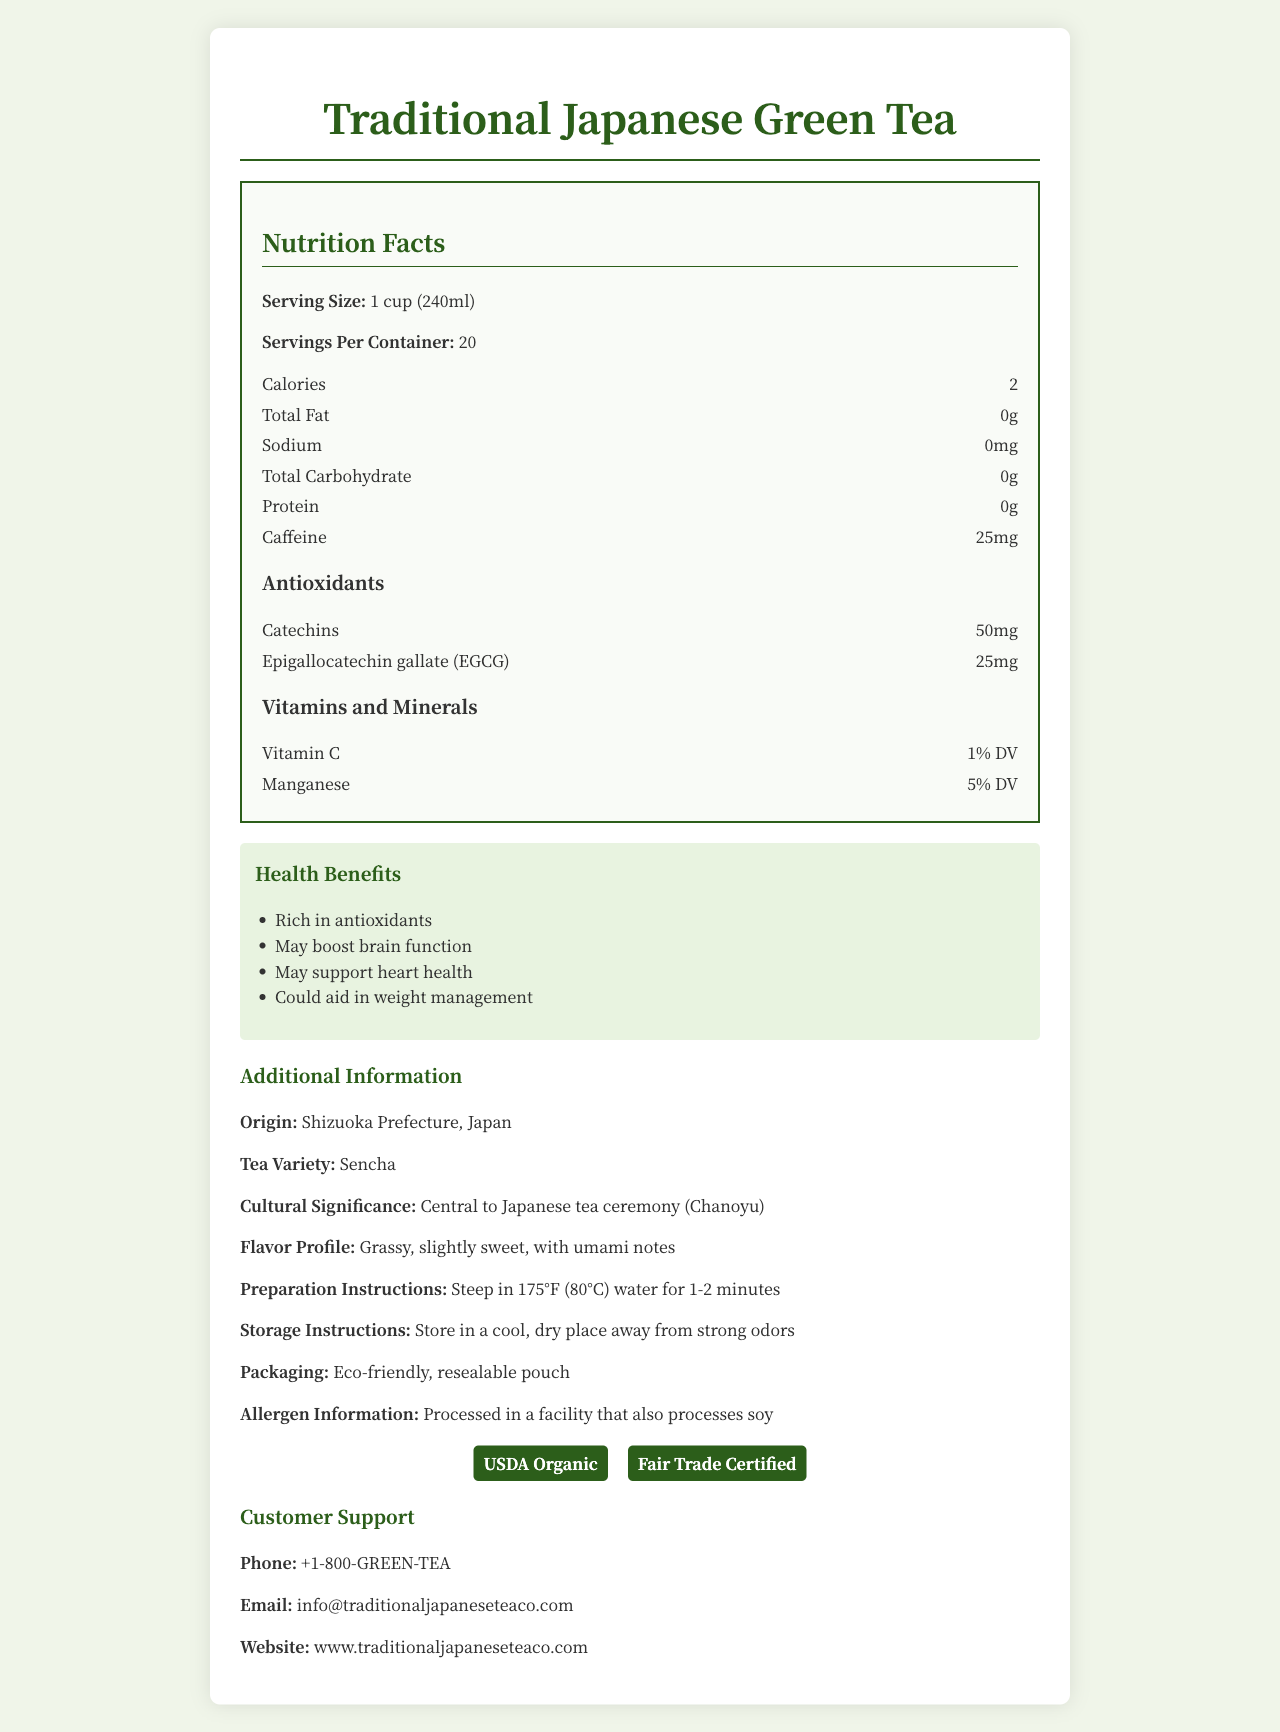what is the serving size of the Traditional Japanese Green Tea? The serving size is explicitly mentioned in the Nutrition Facts section of the document.
Answer: 1 cup (240ml) how many calories are in one serving of this green tea? The document states that each serving of the tea contains 2 calories.
Answer: 2 calories how much caffeine does each serving of the Green Tea contain? The Nutrition Facts section lists the caffeine content per serving as 25mg.
Answer: 25mg what antioxidants are found in this green tea and in what quantities? The Nutrition Facts section under 'Antioxidants' specifies the quantities for Catechins and EGCG.
Answer: Catechins: 50mg, Epigallocatechin gallate (EGCG): 25mg what percentage of the daily value of manganese does one serving provide? The document mentions that each serving provides 5% of the daily value (DV) for manganese.
Answer: 5% DV where is the origin of this green tea? The additional information section lists the origin as Shizuoka Prefecture in Japan.
Answer: Shizuoka Prefecture, Japan which health benefit is NOT listed for the green tea? A. May boost brain function B. Promotes skin health C. May support heart health D. Could aid in weight management The listed health benefits include brain function, heart health, and weight management, but not skin health.
Answer: B what certifications does the Traditional Japanese Green Tea have? A. USDA Organic B. Non-GMO Project Verified C. Fair Trade Certified D. Rainforest Alliance Certified The certifications listed in the document are USDA Organic and Fair Trade Certified.
Answer: A and C is the Traditional Japanese Green Tea allergen-free? The document states that it is processed in a facility that also processes soy, indicating a potential allergen.
Answer: No summarize the main information presented in the document. The document provides comprehensive details about the nutritional content, health benefits, and other key information about Traditional Japanese Green Tea from Shizuoka Prefecture, Japan.
Answer: The document presents the Nutrition Facts for Traditional Japanese Green Tea, including serving size, calorie count, and the content of antioxidants and vitamins. It also details its health benefits, preparation instructions, origin, flavor profile, storage instructions, packaging, certifications, allergen information, and customer support contact. how much sodium is in one serving of the green tea? The Nutrition Facts section clearly shows that each serving contains 0mg of sodium.
Answer: 0mg what percentage of the daily value of vitamin C does one serving provide? The document specifies that each serving provides 1% of the daily value for vitamin C.
Answer: 1% DV what is the tea variety mentioned in the document? It is clearly mentioned under the additional information section that the tea variety is Sencha.
Answer: Sencha how should you prepare the green tea? A. Steep in boiling water for 5-7 minutes B. Steep in 175°F (80°C) water for 1-2 minutes C. Brew at room temperature for 10 minutes D. Use cold water and refrigerate overnight The preparation instructions state to steep the tea in 175°F (80°C) water for 1-2 minutes.
Answer: B what is the cultural significance of this green tea? The document highlights that this green tea is central to the Japanese tea ceremony, known as Chanoyu.
Answer: Central to Japanese tea ceremony (Chanoyu) can you determine the price of the green tea from the document? The document does not provide any details regarding the price of the green tea.
Answer: Not enough information 